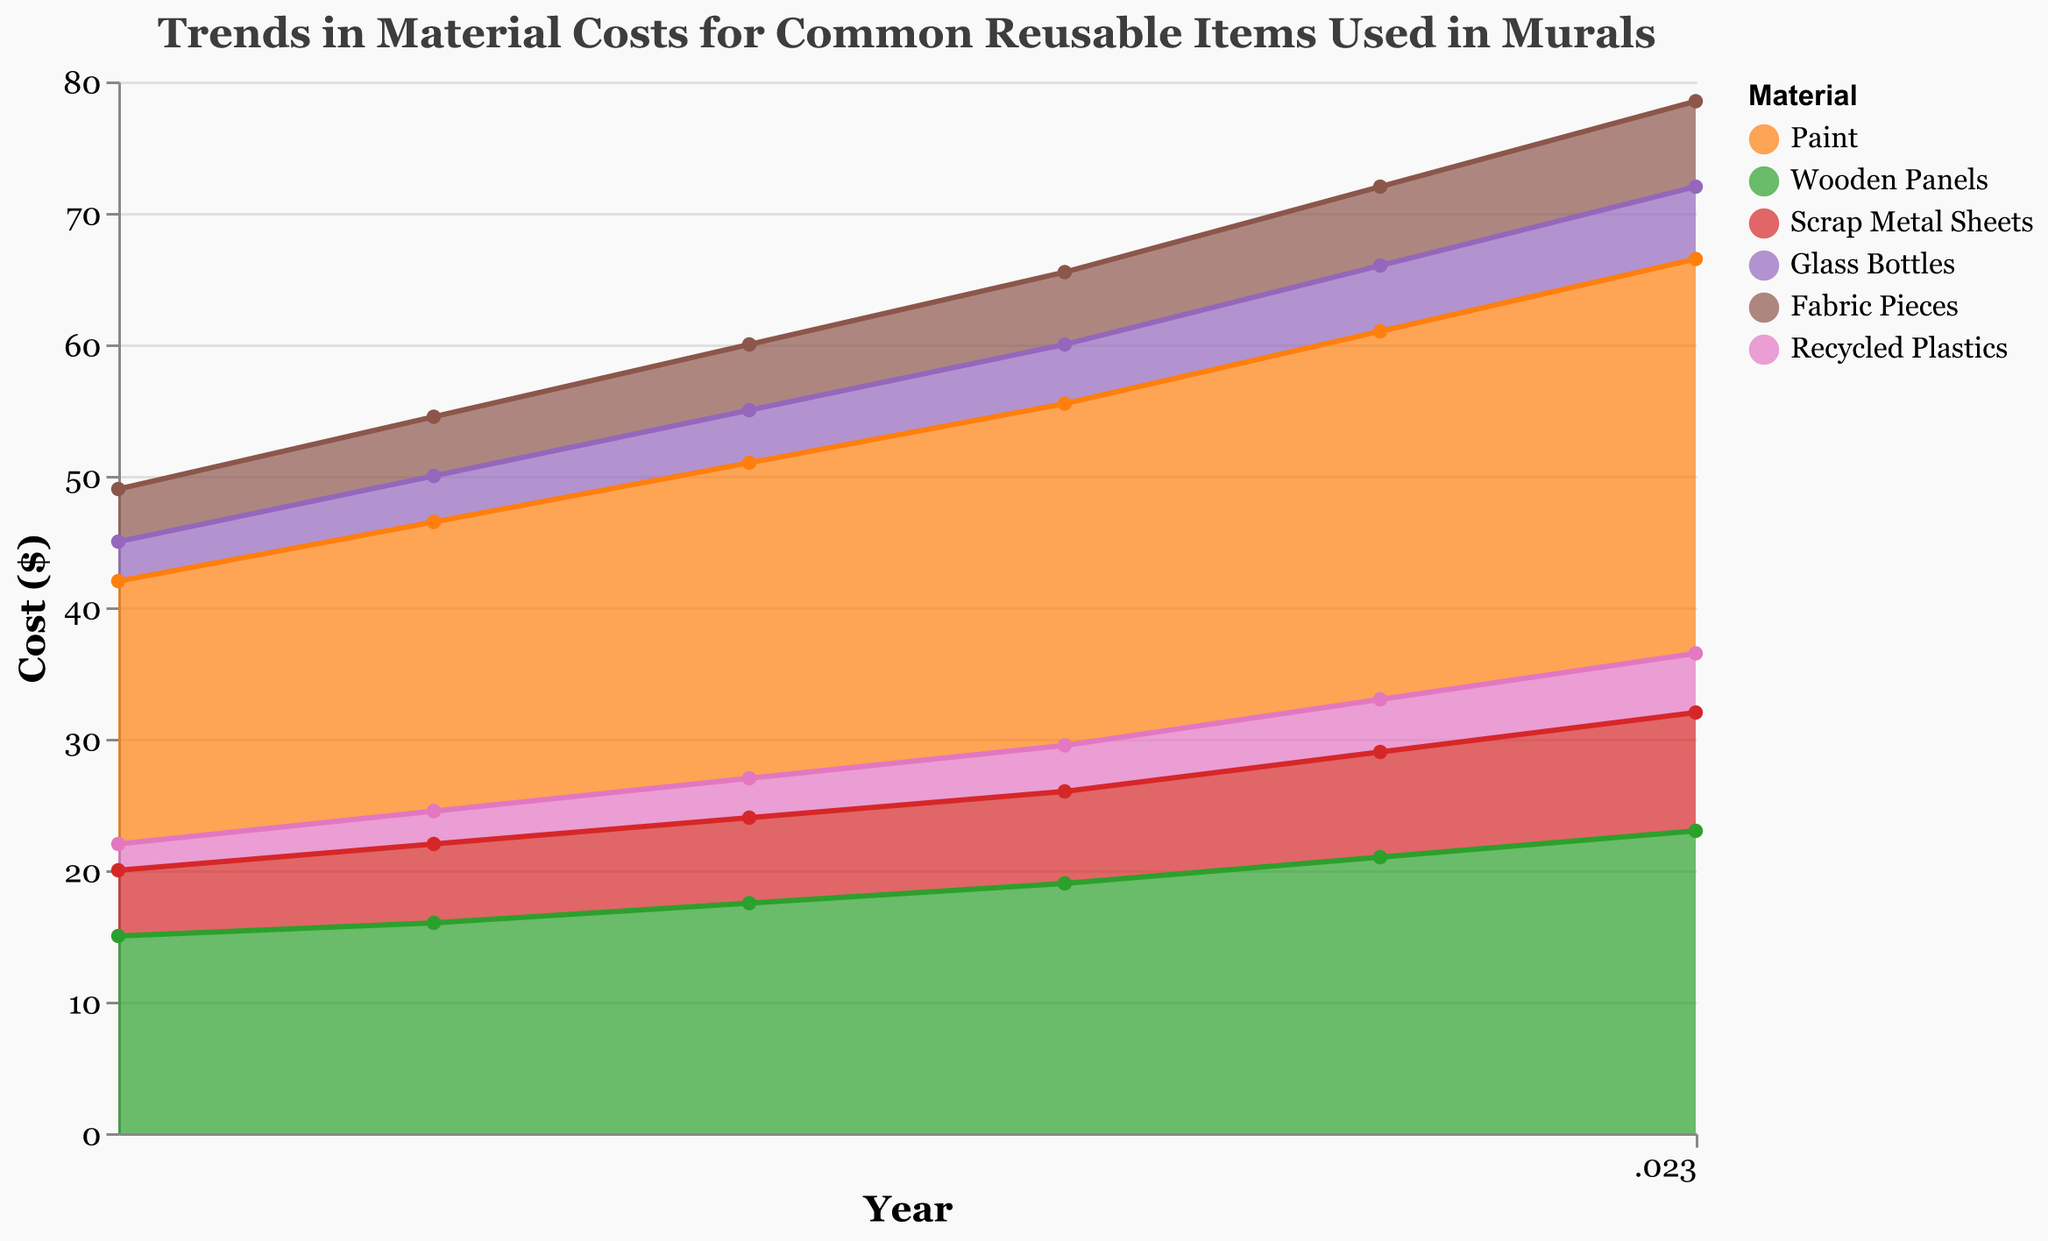What's the title of the chart? The title of the chart is located at the top and provides an overview of the chart's theme. In this case, it states the purpose of the chart.
Answer: Trends in Material Costs for Common Reusable Items Used in Murals Which material has the lowest cost in 2018? Looking at the start of each colored area in the chart for the year 2018, the area with the lowest position on the y-axis represents the material with the lowest cost.
Answer: Recycled Plastics How much did the cost of Scrap Metal Sheets increase from 2019 to 2023? The cost of Scrap Metal Sheets in 2019 can be observed from the relevant colored section, and similarly, the cost in 2023 can be noted from the chart. The increase is calculated by subtracting the 2019 cost from the 2023 cost.
Answer: 3 Which material's cost increased the most over the five-year period? By comparing the size of the increase for each material's area from 2018 to 2023, we can identify which one has the greatest increase in the y-axis.
Answer: Paint How does the cost of Fabric Pieces in 2021 compare to the cost of Glass Bottles in the same year? Locate the values in 2021 for both Fabric Pieces and Glass Bottles on the y-axis and compare them directly to see which one is higher or lower.
Answer: Fabric Pieces are more expensive What is the average cost of Wooden Panels over the five years depicted in the chart? To determine the average, sum the cost of Wooden Panels for each year (2018 to 2023), then divide by the number of years (5).
Answer: 18.75 Which year saw the highest combined cost for all materials? The chart shows the aggregated total cost for each year on the y-axis as the top-most point of the combined areas. Identify the year with the maximum combined height.
Answer: 2023 If the cost of Recycled Plastics continues to increase at the same rate, what would be the estimated cost in 2025? Calculate the rate of increase per year by looking at the annual increase from 2018 to 2023. Then, project the same rate for the next two years.
Answer: 5.5 Are there any years when the cost of Glass Bottles remained the same as the previous year? By examining the line segment for Glass Bottles, check if there are any horizontal lines indicating no change from one year to the next.
Answer: No Between which consecutive years are the changes in the cost of Paint most noticeable? The y-axis differences for Paint between consecutive years should be checked to identify the greatest change.
Answer: 2021-2022 